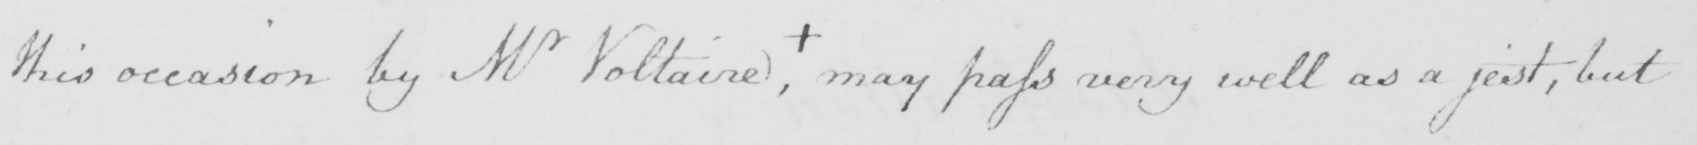What does this handwritten line say? this occasion by Mr Voltaire , +  may pass very well as a jest , but 